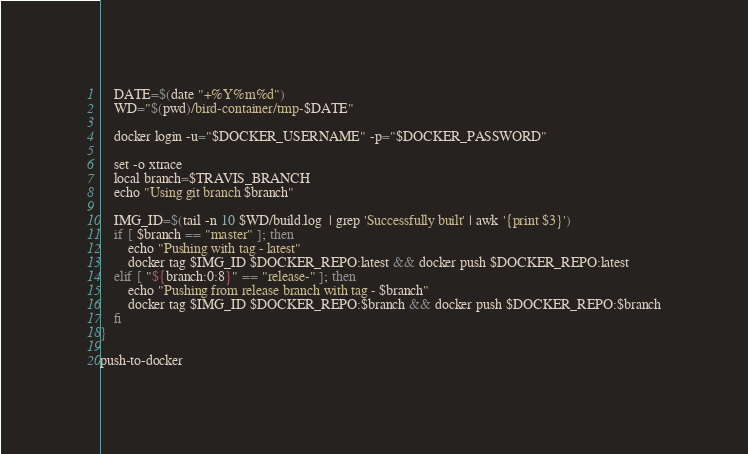Convert code to text. <code><loc_0><loc_0><loc_500><loc_500><_Bash_>    DATE=$(date "+%Y%m%d")
    WD="$(pwd)/bird-container/tmp-$DATE"

    docker login -u="$DOCKER_USERNAME" -p="$DOCKER_PASSWORD"

    set -o xtrace
    local branch=$TRAVIS_BRANCH
    echo "Using git branch $branch"

    IMG_ID=$(tail -n 10 $WD/build.log  | grep 'Successfully built' | awk '{print $3}')
    if [ $branch == "master" ]; then
        echo "Pushing with tag - latest"
        docker tag $IMG_ID $DOCKER_REPO:latest && docker push $DOCKER_REPO:latest
    elif [ "${branch:0:8}" == "release-" ]; then
        echo "Pushing from release branch with tag - $branch"
        docker tag $IMG_ID $DOCKER_REPO:$branch && docker push $DOCKER_REPO:$branch
    fi
}

push-to-docker</code> 